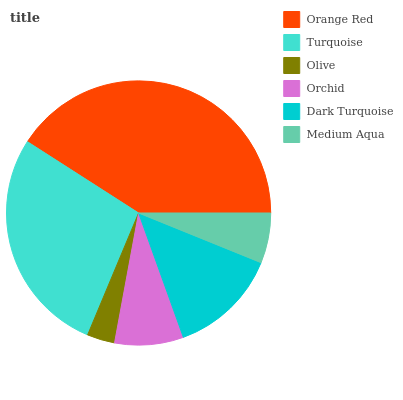Is Olive the minimum?
Answer yes or no. Yes. Is Orange Red the maximum?
Answer yes or no. Yes. Is Turquoise the minimum?
Answer yes or no. No. Is Turquoise the maximum?
Answer yes or no. No. Is Orange Red greater than Turquoise?
Answer yes or no. Yes. Is Turquoise less than Orange Red?
Answer yes or no. Yes. Is Turquoise greater than Orange Red?
Answer yes or no. No. Is Orange Red less than Turquoise?
Answer yes or no. No. Is Dark Turquoise the high median?
Answer yes or no. Yes. Is Orchid the low median?
Answer yes or no. Yes. Is Medium Aqua the high median?
Answer yes or no. No. Is Dark Turquoise the low median?
Answer yes or no. No. 